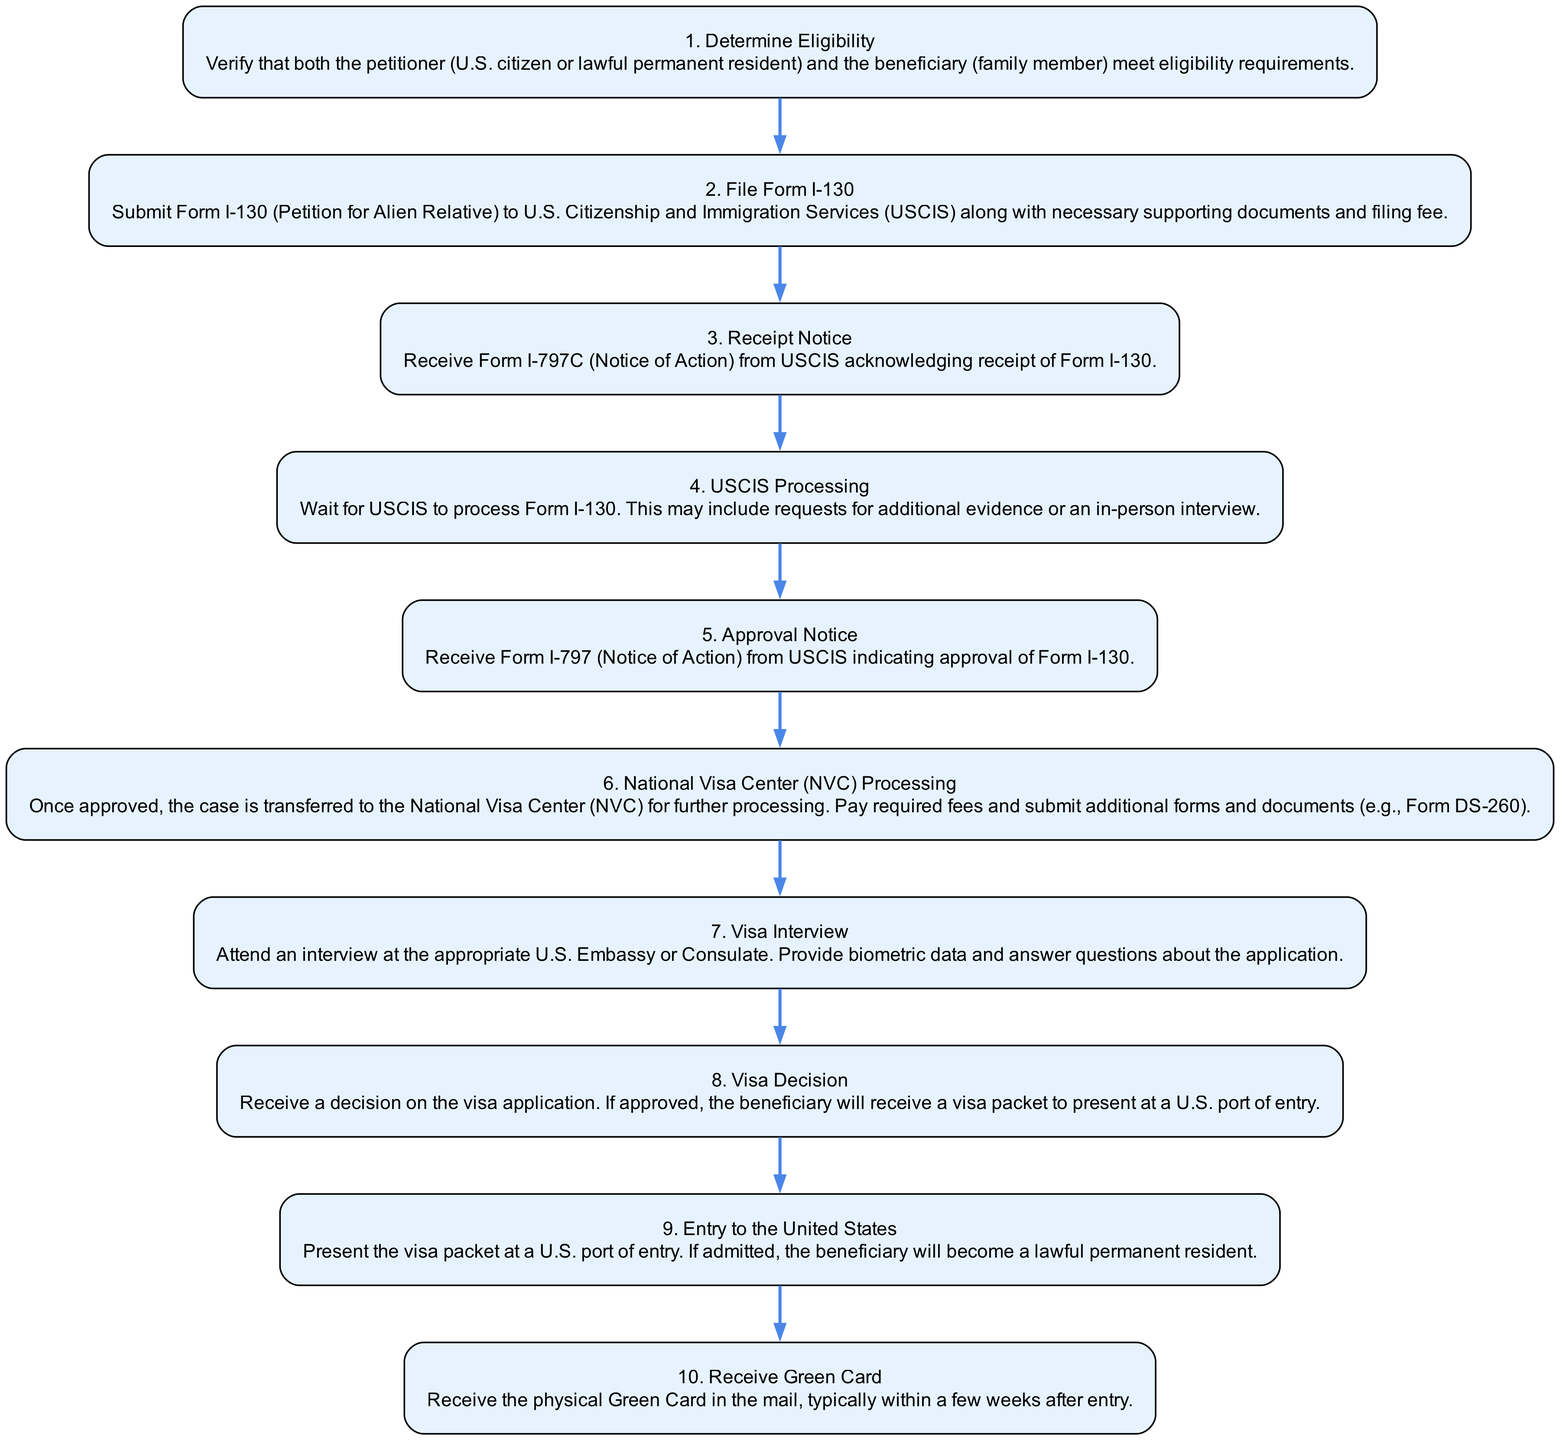What is the first step in the diagram? The first step listed in the diagram is "Determine Eligibility," which is the initial action required before proceeding with the immigration petition process.
Answer: Determine Eligibility How many steps are in the diagram? The diagram includes 10 steps, each representing a key action or decision in the family-based immigration petition process.
Answer: 10 What is the last step in the diagram? The last step shown in the diagram is "Receive Green Card," which represents the final outcome of the immigration petition process once the beneficiary enters the United States.
Answer: Receive Green Card What document is received after filing Form I-130? After filing Form I-130, the document received is Form I-797C (Notice of Action), which acknowledges the receipt of the petition by USCIS.
Answer: Form I-797C Which step involves attending an interview? The step that involves attending an interview is "Visa Interview," where the beneficiary has to answer questions about the application at a U.S. Embassy or Consulate.
Answer: Visa Interview What happens after the Approval Notice? After receiving the Approval Notice, the next step is "National Visa Center (NVC) Processing," where the case is transferred to the NVC for further processing, including fee payments and additional forms.
Answer: National Visa Center (NVC) Processing What is required during the Visa Interview step? During the Visa Interview step, the beneficiary is required to provide biometric data and answer questions regarding the application in front of the consular officer.
Answer: Biometric data What do beneficiaries receive if their visa application is approved? If the visa application is approved, beneficiaries receive a visa packet that they must present at a U.S. port of entry to enter the United States.
Answer: Visa packet In which step does the beneficiary become a lawful permanent resident? The beneficiary becomes a lawful permanent resident in the step "Entry to the United States," when they present their visa packet upon arrival at a U.S. port of entry.
Answer: Entry to the United States 